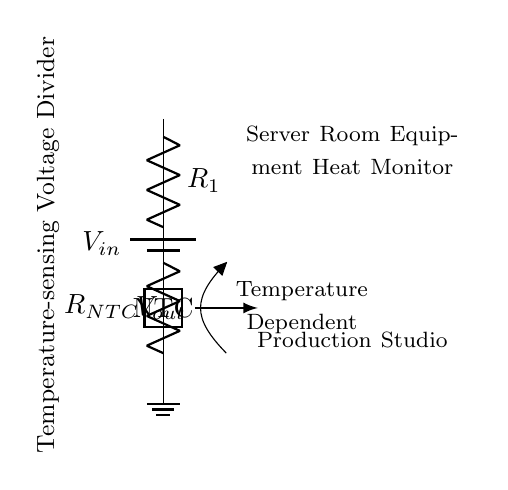What is the input voltage source in this circuit? The circuit diagram shows a battery labeled as Vin, representing the input voltage supply that powers the temperature-sensing voltage divider circuit.
Answer: Vin What type of resistor is used in this circuit? The diagram indicates that there is a resistor specifically labeled as RNTC, which is a negative temperature coefficient (NTC) thermistor. This type of resistor decreases resistance as temperature increases, making it suitable for temperature sensing.
Answer: NTC What does Vout represent in the circuit? In the voltage divider circuit, Vout is indicated as the output voltage, which is the voltage across the NTC thermistor and is dependent on its resistance, which varies with temperature.
Answer: Output voltage How does temperature affect the output voltage Vout? As temperature increases, the resistance of the NTC thermistor decreases, leading to a change in the output voltage (Vout). The relationship is such that an increase in temperature results in a decrease in the output voltage in this circuit configuration.
Answer: Decreases What is the purpose of this circuit? The circuit is designed as a temperature-sensing voltage divider to monitor the heat generated by equipment in a server room, ensuring that temperatures are kept within operational limits.
Answer: Heat monitor Which component in the circuit has temperature-dependent behavior? The NTC thermistor is the component that exhibits temperature-dependent behavior, as its resistance changes inversely with temperature, thereby affecting the output voltage Vout.
Answer: NTC What does the arrow in the circuit indicate? The arrow pointing from the NTC towards the label indicates that the NTC's resistance decreases with an increase in temperature and thus signifies the thermistor's characteristic response to temperature changes.
Answer: Temperature dependent 